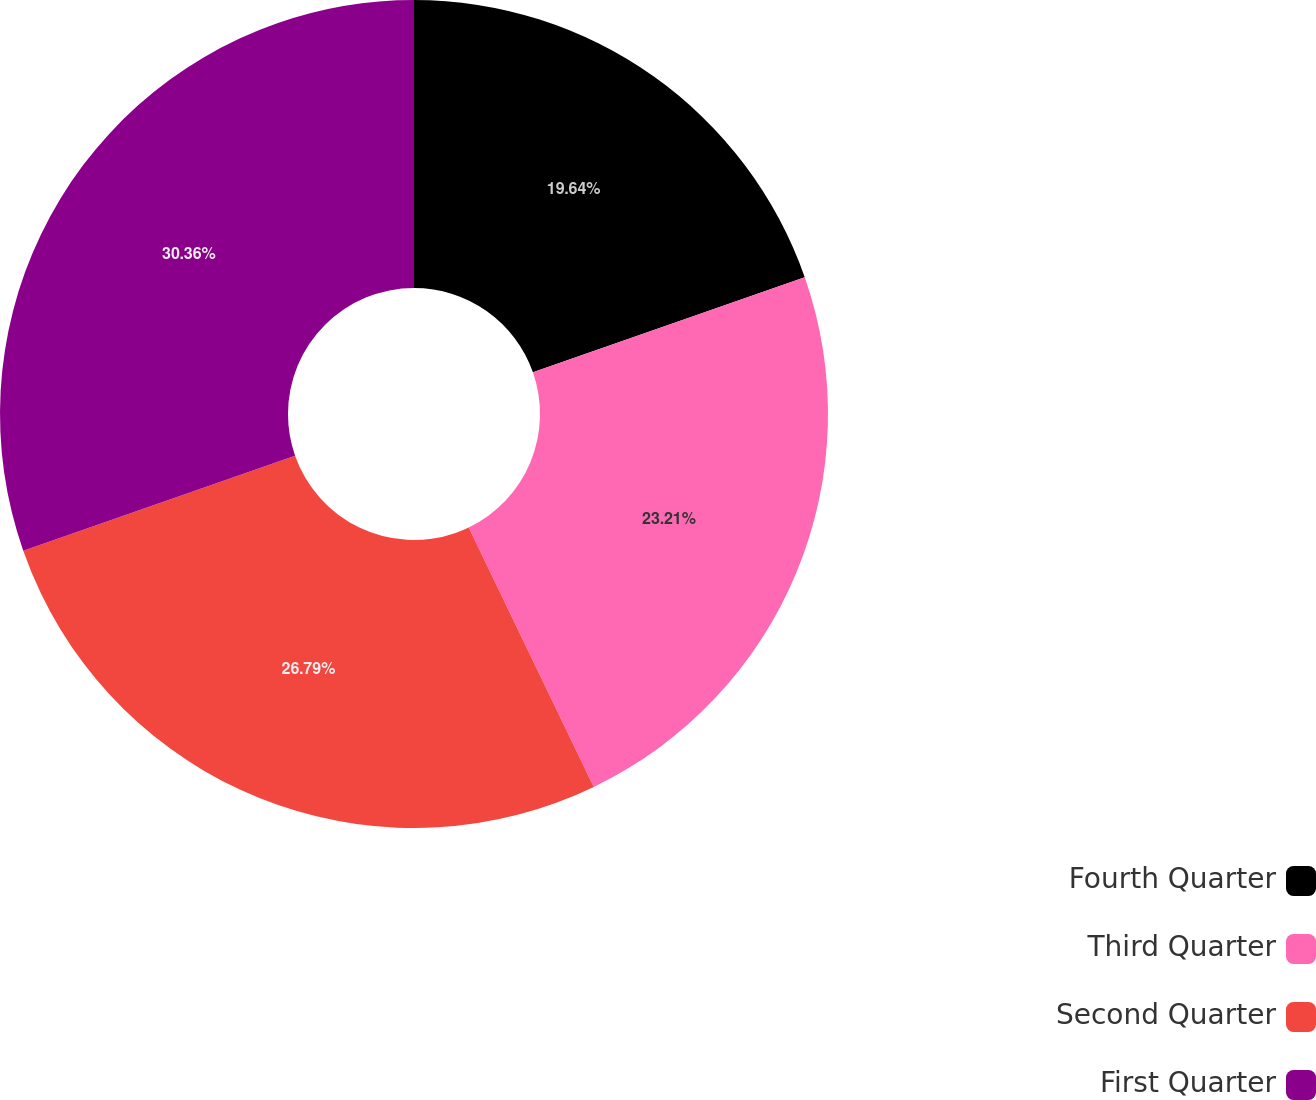Convert chart. <chart><loc_0><loc_0><loc_500><loc_500><pie_chart><fcel>Fourth Quarter<fcel>Third Quarter<fcel>Second Quarter<fcel>First Quarter<nl><fcel>19.64%<fcel>23.21%<fcel>26.79%<fcel>30.36%<nl></chart> 